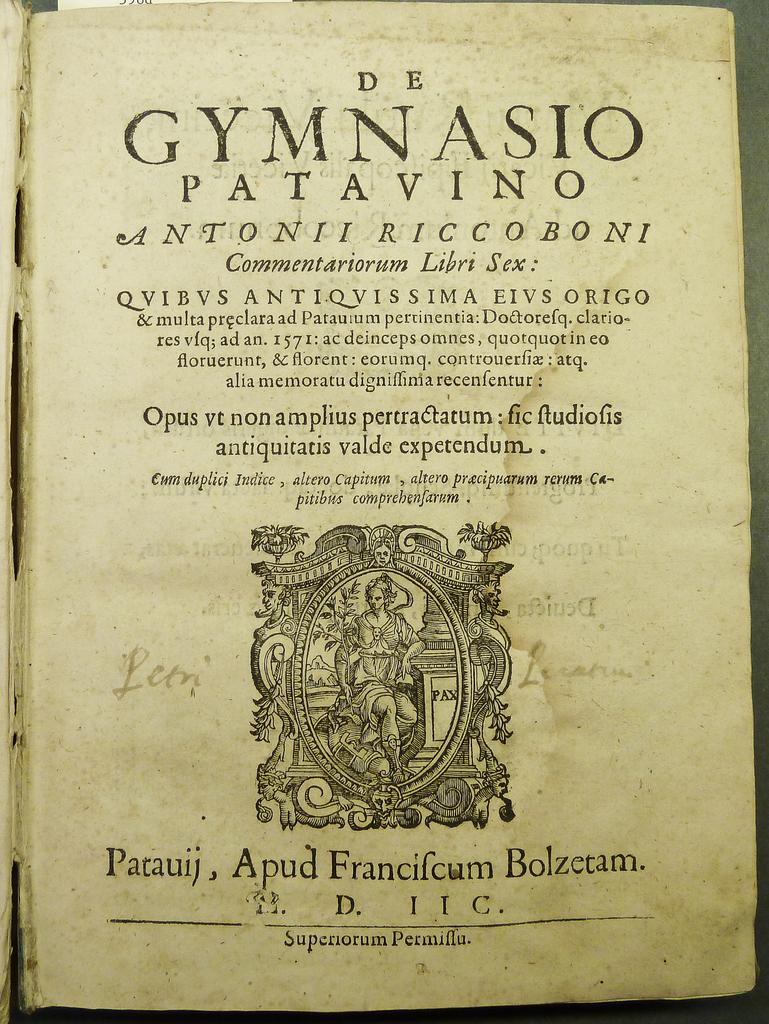What is the name of this book?
Provide a succinct answer. De gymnasio patavino. 